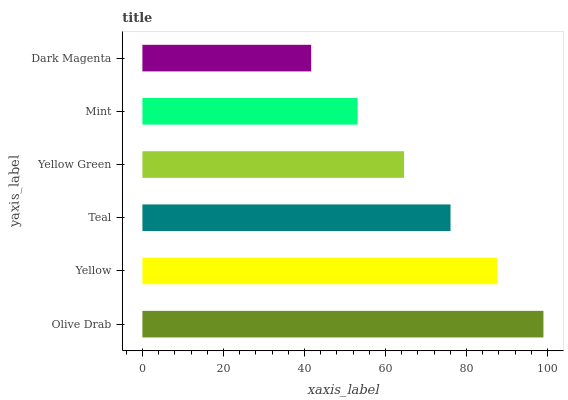Is Dark Magenta the minimum?
Answer yes or no. Yes. Is Olive Drab the maximum?
Answer yes or no. Yes. Is Yellow the minimum?
Answer yes or no. No. Is Yellow the maximum?
Answer yes or no. No. Is Olive Drab greater than Yellow?
Answer yes or no. Yes. Is Yellow less than Olive Drab?
Answer yes or no. Yes. Is Yellow greater than Olive Drab?
Answer yes or no. No. Is Olive Drab less than Yellow?
Answer yes or no. No. Is Teal the high median?
Answer yes or no. Yes. Is Yellow Green the low median?
Answer yes or no. Yes. Is Mint the high median?
Answer yes or no. No. Is Yellow the low median?
Answer yes or no. No. 